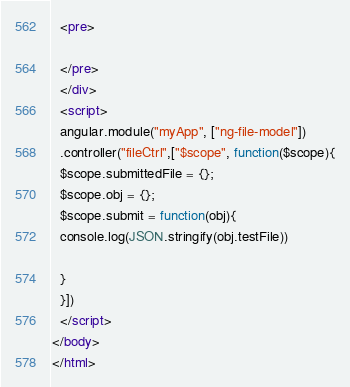<code> <loc_0><loc_0><loc_500><loc_500><_HTML_>  <pre>
  
  </pre>
  </div>
  <script>
  angular.module("myApp", ["ng-file-model"])
  .controller("fileCtrl",["$scope", function($scope){
  $scope.submittedFile = {};
  $scope.obj = {};
  $scope.submit = function(obj){
  console.log(JSON.stringify(obj.testFile))
  
  }
  }])
  </script>
</body>
</html>
</code> 